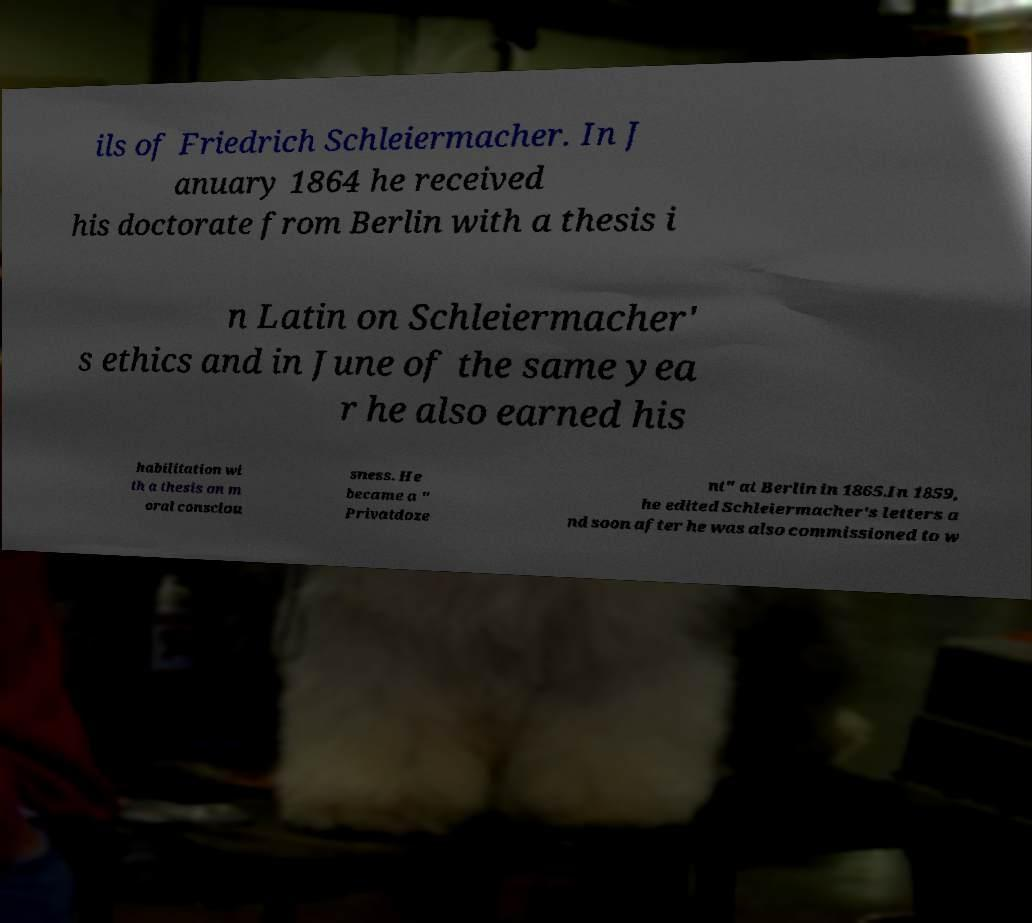Could you extract and type out the text from this image? ils of Friedrich Schleiermacher. In J anuary 1864 he received his doctorate from Berlin with a thesis i n Latin on Schleiermacher' s ethics and in June of the same yea r he also earned his habilitation wi th a thesis on m oral consciou sness. He became a " Privatdoze nt" at Berlin in 1865.In 1859, he edited Schleiermacher's letters a nd soon after he was also commissioned to w 